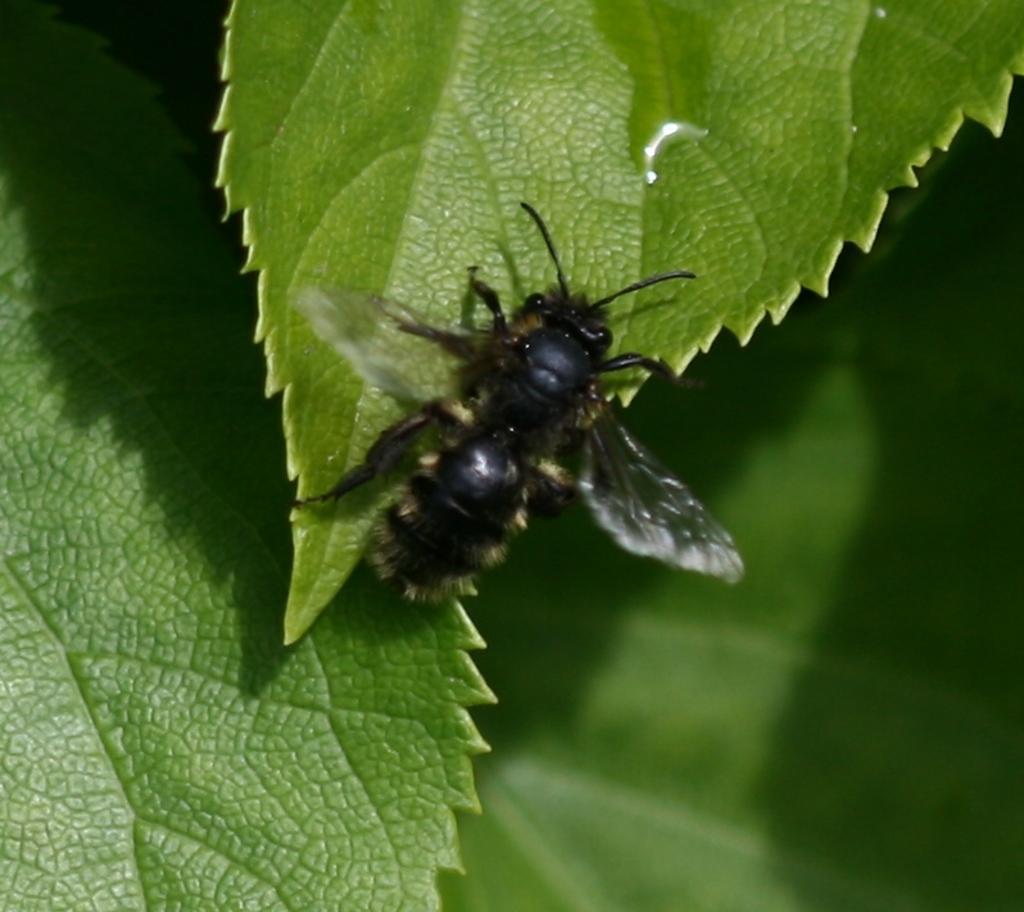Please provide a concise description of this image. In this image we can see an insect on the leaf. In the background there are leaves. 